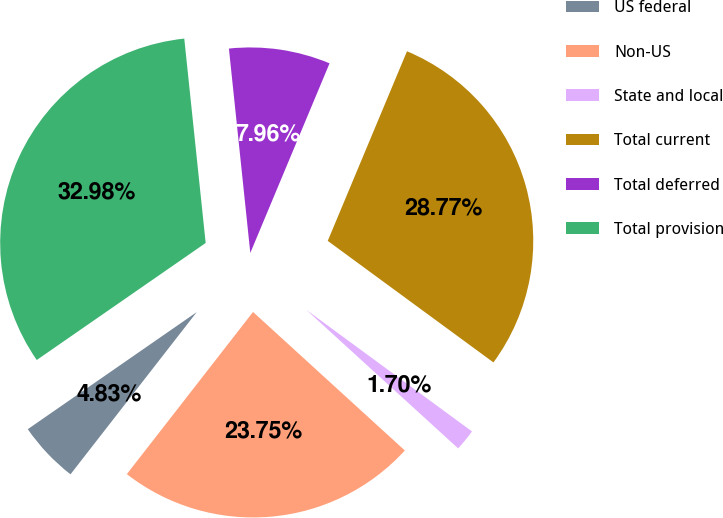<chart> <loc_0><loc_0><loc_500><loc_500><pie_chart><fcel>US federal<fcel>Non-US<fcel>State and local<fcel>Total current<fcel>Total deferred<fcel>Total provision<nl><fcel>4.83%<fcel>23.75%<fcel>1.7%<fcel>28.77%<fcel>7.96%<fcel>32.98%<nl></chart> 